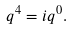Convert formula to latex. <formula><loc_0><loc_0><loc_500><loc_500>q ^ { 4 } = i q ^ { 0 } .</formula> 